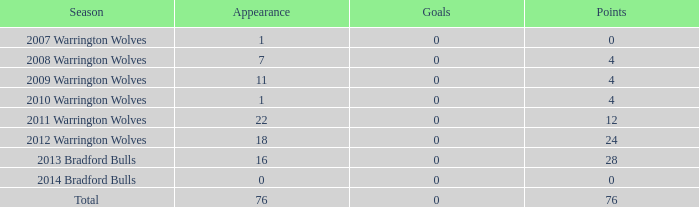What is the average number of tries for the 2008 warrington wolves with a presence exceeding 7? None. 